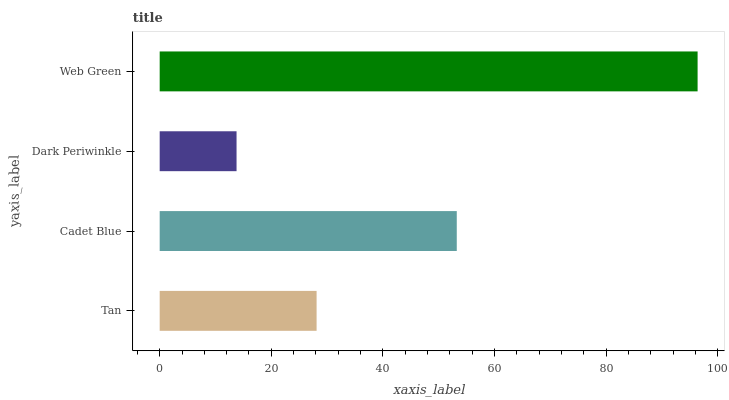Is Dark Periwinkle the minimum?
Answer yes or no. Yes. Is Web Green the maximum?
Answer yes or no. Yes. Is Cadet Blue the minimum?
Answer yes or no. No. Is Cadet Blue the maximum?
Answer yes or no. No. Is Cadet Blue greater than Tan?
Answer yes or no. Yes. Is Tan less than Cadet Blue?
Answer yes or no. Yes. Is Tan greater than Cadet Blue?
Answer yes or no. No. Is Cadet Blue less than Tan?
Answer yes or no. No. Is Cadet Blue the high median?
Answer yes or no. Yes. Is Tan the low median?
Answer yes or no. Yes. Is Tan the high median?
Answer yes or no. No. Is Cadet Blue the low median?
Answer yes or no. No. 